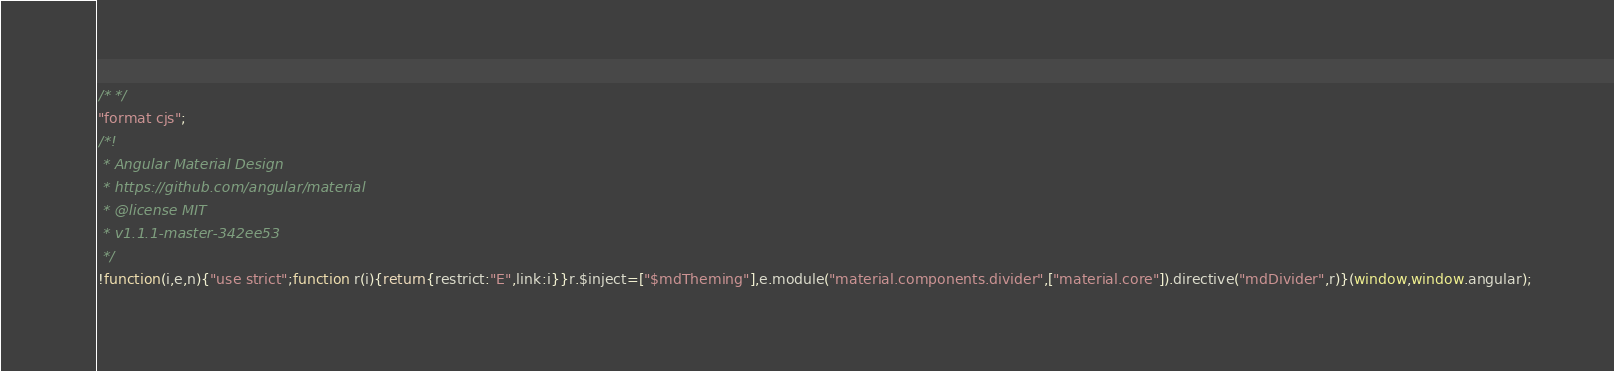<code> <loc_0><loc_0><loc_500><loc_500><_JavaScript_>/* */ 
"format cjs";
/*!
 * Angular Material Design
 * https://github.com/angular/material
 * @license MIT
 * v1.1.1-master-342ee53
 */
!function(i,e,n){"use strict";function r(i){return{restrict:"E",link:i}}r.$inject=["$mdTheming"],e.module("material.components.divider",["material.core"]).directive("mdDivider",r)}(window,window.angular);</code> 